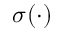Convert formula to latex. <formula><loc_0><loc_0><loc_500><loc_500>\sigma ( \cdot )</formula> 